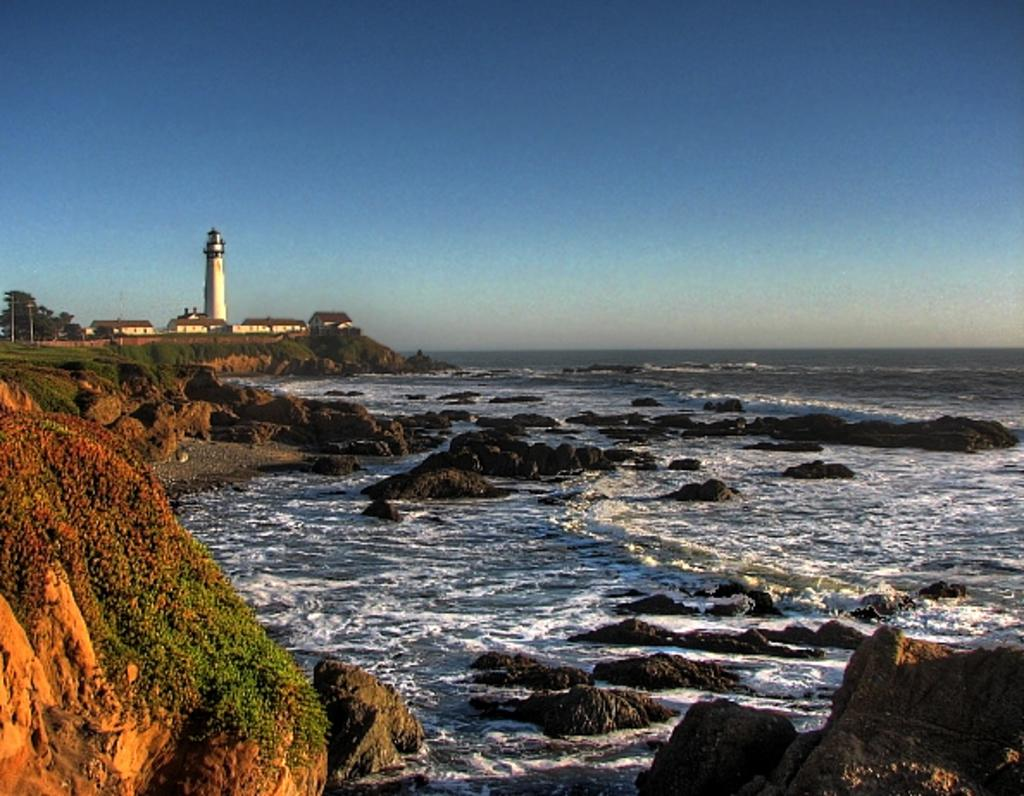What is located in the foreground of the image? There is a rock and water in the foreground of the image. What can be seen in the background of the image? There are rocks, water, a lighthouse, buildings, trees, poles, and the sky visible in the background of the image. Can you see any fairies flying around the lighthouse in the image? There are no fairies present in the image; it only features rocks, water, a lighthouse, buildings, trees, poles, and the sky. What type of shock can be seen affecting the rock in the foreground of the image? There is no shock present in the image; it only features rocks, water, a lighthouse, buildings, trees, poles, and the sky. 